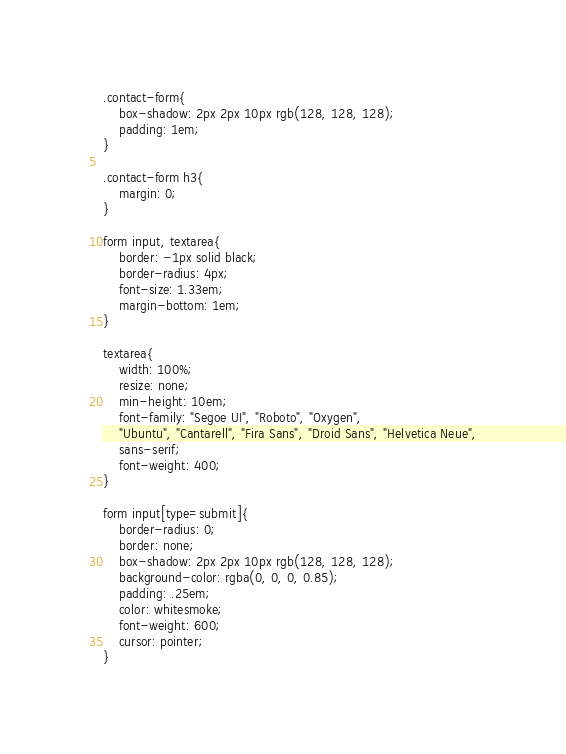Convert code to text. <code><loc_0><loc_0><loc_500><loc_500><_CSS_>.contact-form{
    box-shadow: 2px 2px 10px rgb(128, 128, 128);
    padding: 1em;
}

.contact-form h3{
    margin: 0;
}

form input, textarea{
    border: -1px solid black;
    border-radius: 4px;
    font-size: 1.33em;
    margin-bottom: 1em;
}

textarea{
    width: 100%;
    resize: none;
    min-height: 10em;
    font-family: "Segoe UI", "Roboto", "Oxygen",
    "Ubuntu", "Cantarell", "Fira Sans", "Droid Sans", "Helvetica Neue",
    sans-serif;
    font-weight: 400;
}

form input[type=submit]{
    border-radius: 0;
    border: none;
    box-shadow: 2px 2px 10px rgb(128, 128, 128);
    background-color: rgba(0, 0, 0, 0.85);
    padding: .25em;
    color: whitesmoke;
    font-weight: 600;
    cursor: pointer;
}</code> 